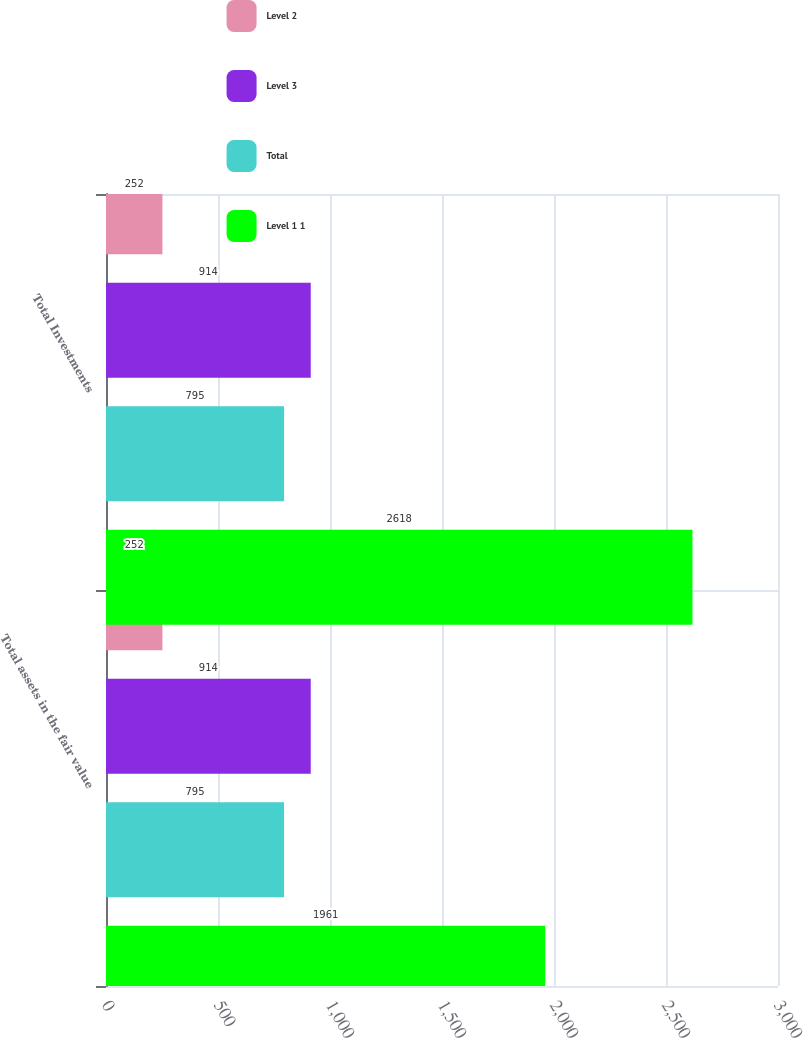Convert chart to OTSL. <chart><loc_0><loc_0><loc_500><loc_500><stacked_bar_chart><ecel><fcel>Total assets in the fair value<fcel>Total Investments<nl><fcel>Level 2<fcel>252<fcel>252<nl><fcel>Level 3<fcel>914<fcel>914<nl><fcel>Total<fcel>795<fcel>795<nl><fcel>Level 1 1<fcel>1961<fcel>2618<nl></chart> 